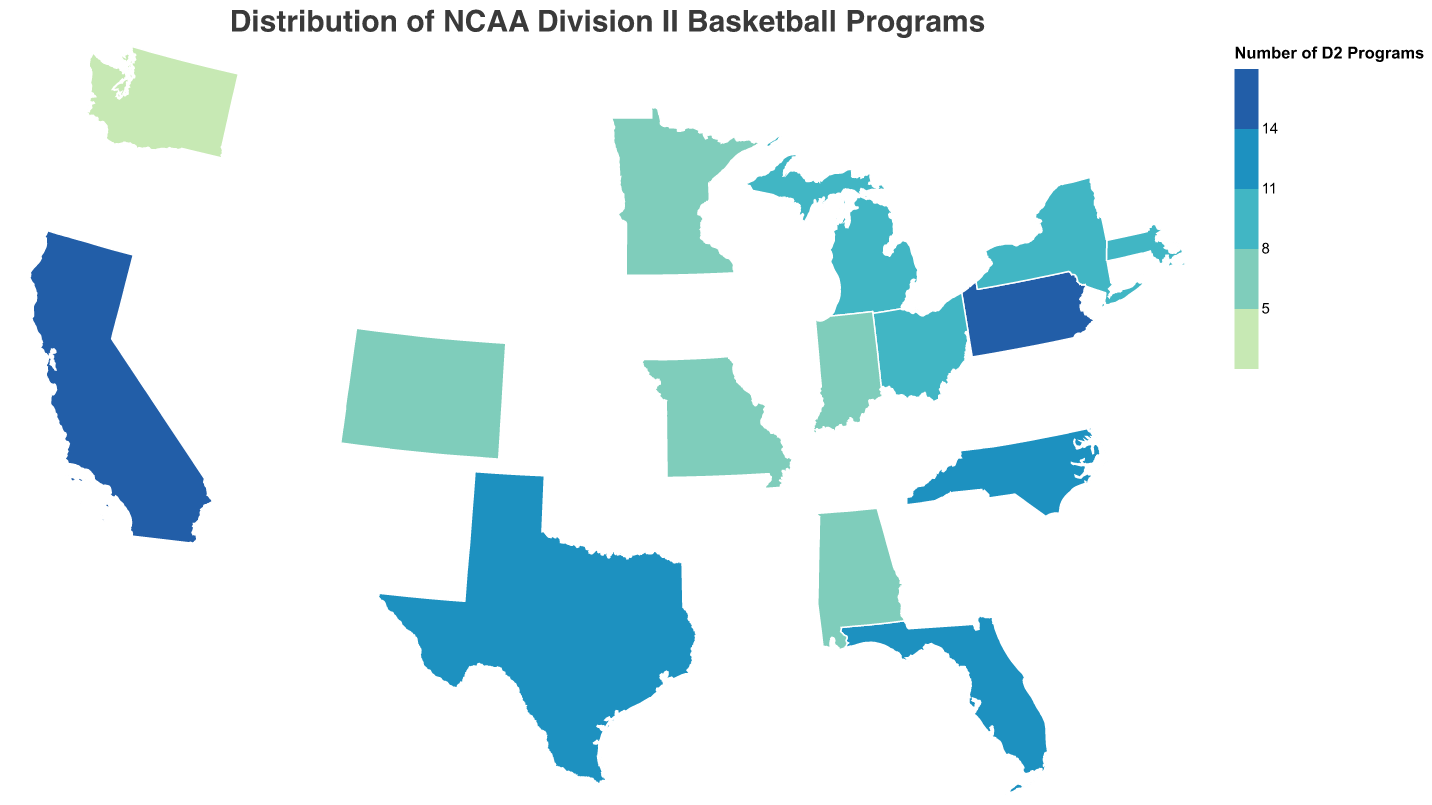What's the title of the chart? The title of the chart is displayed at the top and reads "Distribution of NCAA Division II Basketball Programs".
Answer: Distribution of NCAA Division II Basketball Programs Which state has the most NCAA Division II basketball programs? By looking at the color and the tooltip information, California has the most NCAA Division II basketball programs with a total of 15.
Answer: California How many states have exactly 6 NCAA Division II basketball programs? By checking the color encoding and tooltips, there are two states with exactly 6 programs: Missouri and Indiana.
Answer: 2 What is the notable Division II basketball program in New York? According to the tooltip for New York, the notable Division II basketball program is Le Moyne College.
Answer: Le Moyne College Which state has fewer Division II basketball programs, Washington or Colorado? By comparing the states' colors and tooltips, Washington has 4 programs while Colorado has 7. Therefore, Washington has fewer programs.
Answer: Washington What is the combined number of Division II basketball programs in Texas and North Carolina? Texas has 11 programs and North Carolina also has 11 according to the tooltips. Combined, they have 11 + 11 = 22 programs.
Answer: 22 Which state, among Florida, Michigan, and Ohio, has the most Division II basketball programs? Florida has 12 programs, Michigan has 9, and Ohio has 8. Therefore, Florida has the most programs among these states.
Answer: Florida What is the median number of Division II basketball programs across all listed states? To find the median, list the number of programs for each state (4, 5, 5, 6, 6, 7, 8, 9, 9, 10, 11, 11, 12, 14, 15) and find the middle value. The median is 9.
Answer: 9 What is the color representing the states with 5 NCAA Division II basketball programs? According to the scale provided in the plot's legend, states with 5 programs are colored in the shade that matches "#c7e9b4".
Answer: light green 